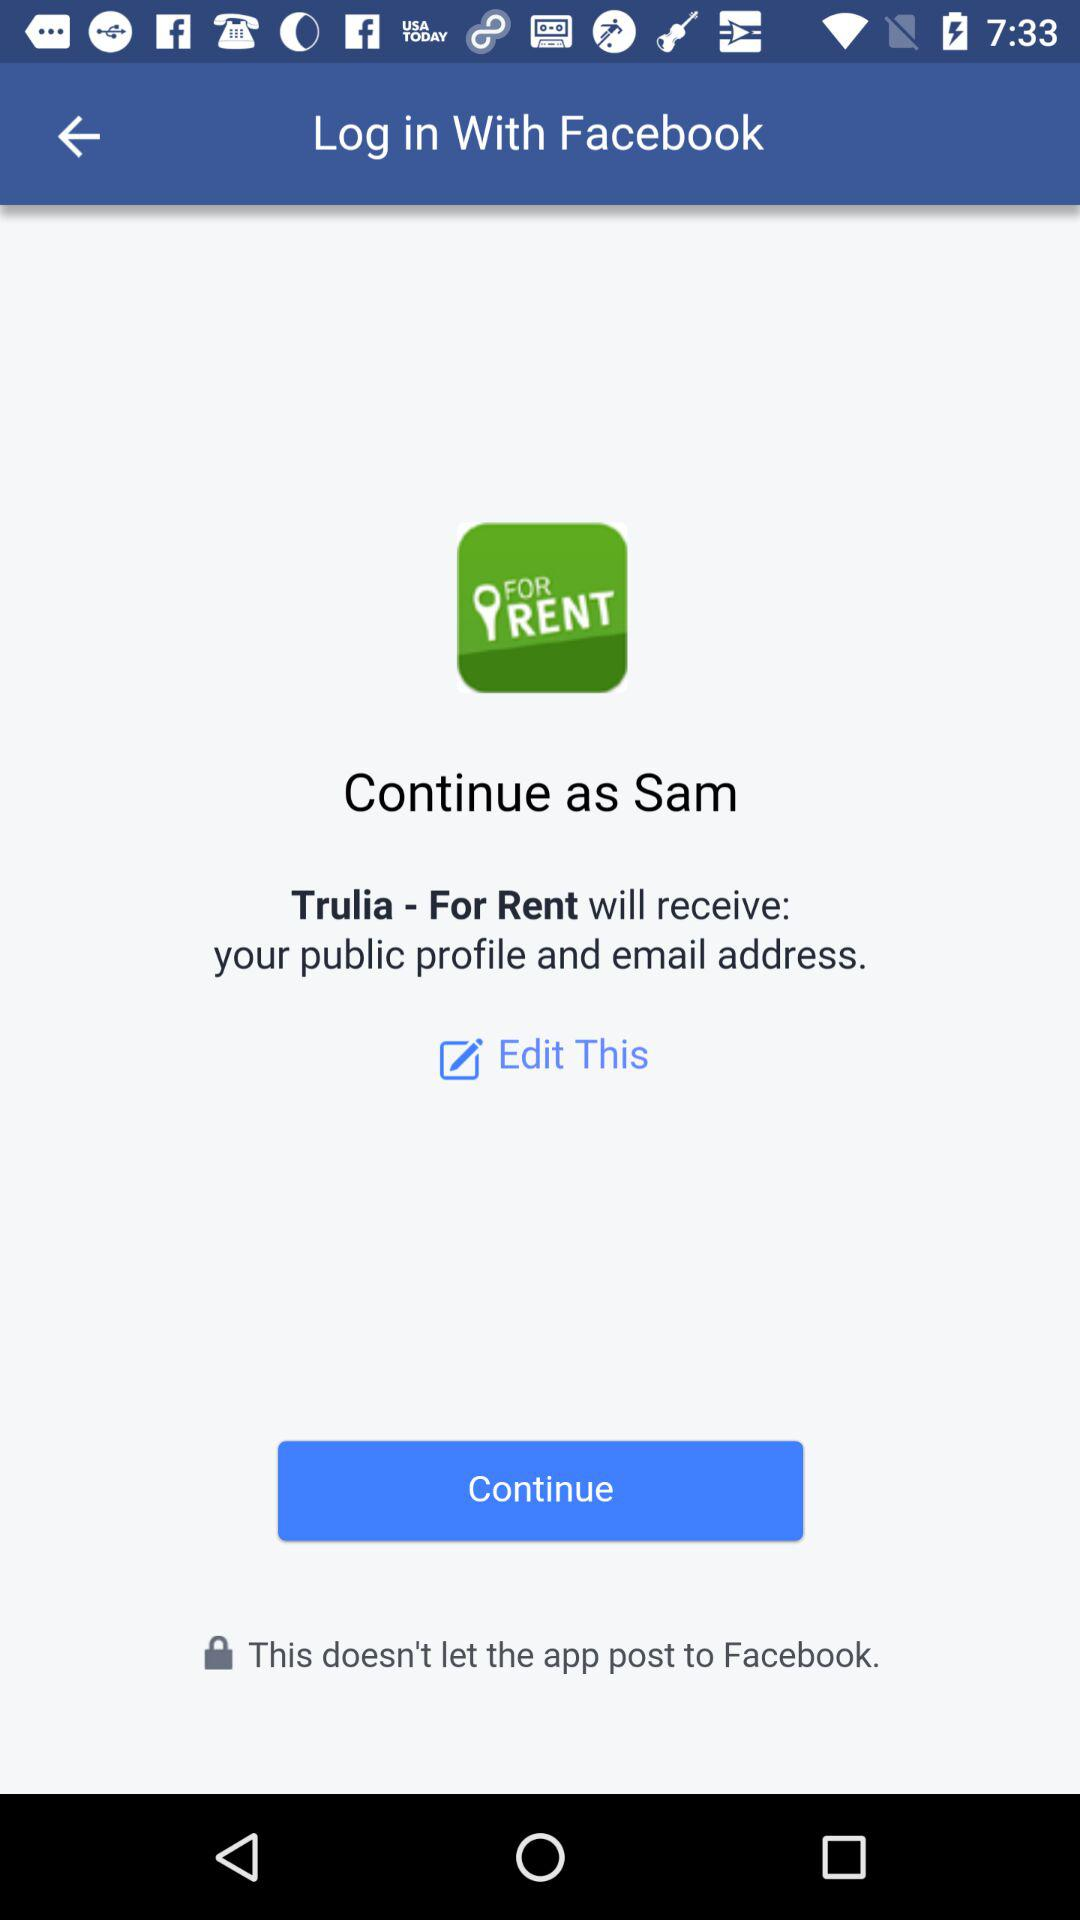Through what application can the person log in? The person can log in through "Facebook". 